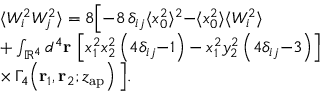Convert formula to latex. <formula><loc_0><loc_0><loc_500><loc_500>\begin{array} { r l } & { \langle W _ { i } ^ { 2 } W _ { j } ^ { 2 } \rangle = 8 \left [ { - } 8 \, \delta _ { i j } \langle x _ { 0 } ^ { 2 } \rangle ^ { 2 } { - } \langle x _ { 0 } ^ { 2 } \rangle \langle W _ { i } ^ { 2 } \rangle } \\ & { + \int _ { \mathbb { R } ^ { 4 } } d ^ { 4 } r \, \left [ x _ { 1 } ^ { 2 } x _ { 2 } ^ { 2 } \left ( 4 \delta _ { i j } { - } 1 \right ) - x _ { 1 } ^ { 2 } y _ { 2 } ^ { 2 } \left ( 4 \delta _ { i j } { - } 3 \right ) \right ] } \\ & { \times \, \Gamma _ { 4 } \, \left ( r _ { 1 } , r _ { 2 } ; z _ { a p } \right ) \right ] . } \end{array}</formula> 